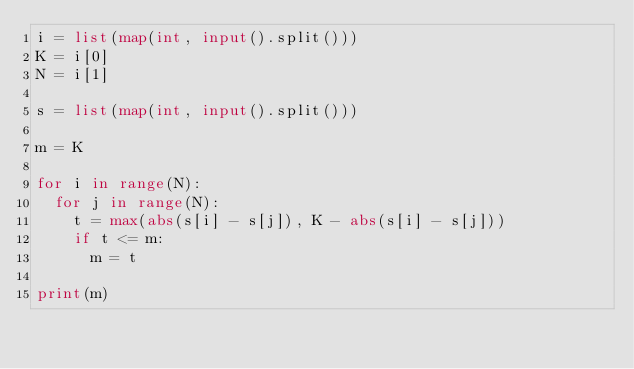<code> <loc_0><loc_0><loc_500><loc_500><_Python_>i = list(map(int, input().split()))
K = i[0]
N = i[1]

s = list(map(int, input().split()))

m = K

for i in range(N):
  for j in range(N):
    t = max(abs(s[i] - s[j]), K - abs(s[i] - s[j]))
    if t <= m:
      m = t
      
print(m)</code> 